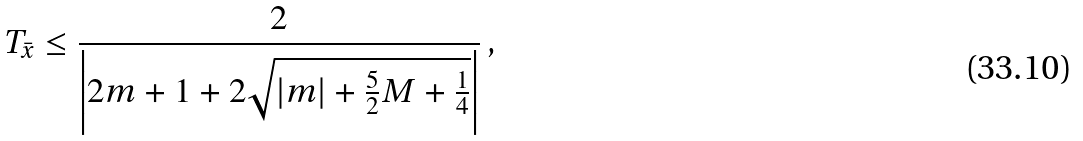<formula> <loc_0><loc_0><loc_500><loc_500>T _ { \bar { x } } \leq \frac { 2 } { \left | 2 m + 1 + 2 \sqrt { | m | + \frac { 5 } { 2 } M + \frac { 1 } { 4 } } \right | } \, ,</formula> 